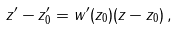Convert formula to latex. <formula><loc_0><loc_0><loc_500><loc_500>z ^ { \prime } - z ^ { \prime } _ { 0 } = w ^ { \prime } ( z _ { 0 } ) ( z - z _ { 0 } ) \, ,</formula> 